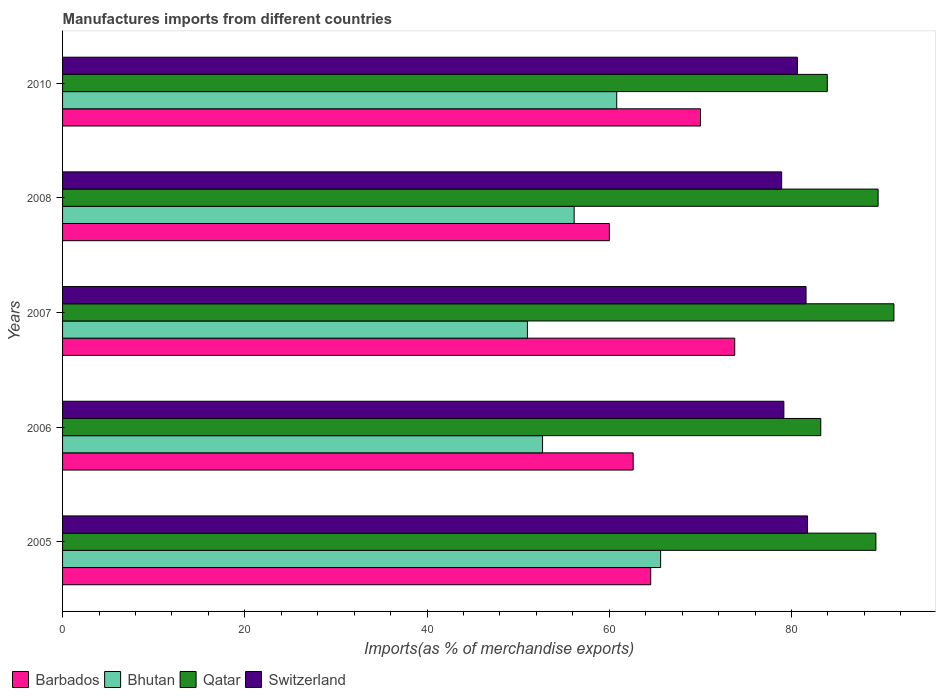How many different coloured bars are there?
Your response must be concise. 4. How many groups of bars are there?
Your answer should be compact. 5. Are the number of bars per tick equal to the number of legend labels?
Your answer should be very brief. Yes. How many bars are there on the 5th tick from the top?
Ensure brevity in your answer.  4. What is the label of the 2nd group of bars from the top?
Give a very brief answer. 2008. In how many cases, is the number of bars for a given year not equal to the number of legend labels?
Your response must be concise. 0. What is the percentage of imports to different countries in Barbados in 2010?
Your response must be concise. 70.01. Across all years, what is the maximum percentage of imports to different countries in Bhutan?
Keep it short and to the point. 65.64. Across all years, what is the minimum percentage of imports to different countries in Bhutan?
Offer a terse response. 51.02. What is the total percentage of imports to different countries in Barbados in the graph?
Ensure brevity in your answer.  330.98. What is the difference between the percentage of imports to different countries in Qatar in 2005 and that in 2010?
Offer a terse response. 5.34. What is the difference between the percentage of imports to different countries in Barbados in 2010 and the percentage of imports to different countries in Bhutan in 2006?
Give a very brief answer. 17.33. What is the average percentage of imports to different countries in Qatar per year?
Your response must be concise. 87.43. In the year 2005, what is the difference between the percentage of imports to different countries in Barbados and percentage of imports to different countries in Switzerland?
Your answer should be very brief. -17.21. What is the ratio of the percentage of imports to different countries in Switzerland in 2005 to that in 2007?
Provide a succinct answer. 1. Is the percentage of imports to different countries in Switzerland in 2008 less than that in 2010?
Your answer should be very brief. Yes. What is the difference between the highest and the second highest percentage of imports to different countries in Barbados?
Provide a succinct answer. 3.76. What is the difference between the highest and the lowest percentage of imports to different countries in Barbados?
Keep it short and to the point. 13.76. In how many years, is the percentage of imports to different countries in Barbados greater than the average percentage of imports to different countries in Barbados taken over all years?
Your response must be concise. 2. Is the sum of the percentage of imports to different countries in Barbados in 2005 and 2008 greater than the maximum percentage of imports to different countries in Qatar across all years?
Your answer should be compact. Yes. What does the 2nd bar from the top in 2010 represents?
Give a very brief answer. Qatar. What does the 4th bar from the bottom in 2007 represents?
Make the answer very short. Switzerland. Is it the case that in every year, the sum of the percentage of imports to different countries in Switzerland and percentage of imports to different countries in Bhutan is greater than the percentage of imports to different countries in Barbados?
Give a very brief answer. Yes. How many bars are there?
Provide a succinct answer. 20. What is the difference between two consecutive major ticks on the X-axis?
Make the answer very short. 20. Are the values on the major ticks of X-axis written in scientific E-notation?
Offer a terse response. No. Does the graph contain any zero values?
Offer a terse response. No. How are the legend labels stacked?
Ensure brevity in your answer.  Horizontal. What is the title of the graph?
Give a very brief answer. Manufactures imports from different countries. What is the label or title of the X-axis?
Keep it short and to the point. Imports(as % of merchandise exports). What is the label or title of the Y-axis?
Your answer should be compact. Years. What is the Imports(as % of merchandise exports) of Barbados in 2005?
Give a very brief answer. 64.55. What is the Imports(as % of merchandise exports) in Bhutan in 2005?
Keep it short and to the point. 65.64. What is the Imports(as % of merchandise exports) of Qatar in 2005?
Give a very brief answer. 89.27. What is the Imports(as % of merchandise exports) of Switzerland in 2005?
Keep it short and to the point. 81.76. What is the Imports(as % of merchandise exports) of Barbados in 2006?
Keep it short and to the point. 62.63. What is the Imports(as % of merchandise exports) in Bhutan in 2006?
Keep it short and to the point. 52.68. What is the Imports(as % of merchandise exports) of Qatar in 2006?
Provide a short and direct response. 83.21. What is the Imports(as % of merchandise exports) of Switzerland in 2006?
Your answer should be very brief. 79.17. What is the Imports(as % of merchandise exports) of Barbados in 2007?
Your answer should be very brief. 73.77. What is the Imports(as % of merchandise exports) in Bhutan in 2007?
Give a very brief answer. 51.02. What is the Imports(as % of merchandise exports) in Qatar in 2007?
Make the answer very short. 91.24. What is the Imports(as % of merchandise exports) in Switzerland in 2007?
Provide a short and direct response. 81.6. What is the Imports(as % of merchandise exports) of Barbados in 2008?
Ensure brevity in your answer.  60.01. What is the Imports(as % of merchandise exports) of Bhutan in 2008?
Your answer should be compact. 56.15. What is the Imports(as % of merchandise exports) in Qatar in 2008?
Offer a terse response. 89.51. What is the Imports(as % of merchandise exports) in Switzerland in 2008?
Offer a terse response. 78.92. What is the Imports(as % of merchandise exports) in Barbados in 2010?
Provide a short and direct response. 70.01. What is the Imports(as % of merchandise exports) of Bhutan in 2010?
Your response must be concise. 60.82. What is the Imports(as % of merchandise exports) of Qatar in 2010?
Keep it short and to the point. 83.93. What is the Imports(as % of merchandise exports) in Switzerland in 2010?
Ensure brevity in your answer.  80.65. Across all years, what is the maximum Imports(as % of merchandise exports) in Barbados?
Offer a very short reply. 73.77. Across all years, what is the maximum Imports(as % of merchandise exports) in Bhutan?
Ensure brevity in your answer.  65.64. Across all years, what is the maximum Imports(as % of merchandise exports) of Qatar?
Provide a short and direct response. 91.24. Across all years, what is the maximum Imports(as % of merchandise exports) in Switzerland?
Keep it short and to the point. 81.76. Across all years, what is the minimum Imports(as % of merchandise exports) in Barbados?
Your answer should be compact. 60.01. Across all years, what is the minimum Imports(as % of merchandise exports) of Bhutan?
Ensure brevity in your answer.  51.02. Across all years, what is the minimum Imports(as % of merchandise exports) in Qatar?
Ensure brevity in your answer.  83.21. Across all years, what is the minimum Imports(as % of merchandise exports) of Switzerland?
Your answer should be very brief. 78.92. What is the total Imports(as % of merchandise exports) of Barbados in the graph?
Provide a short and direct response. 330.98. What is the total Imports(as % of merchandise exports) of Bhutan in the graph?
Provide a succinct answer. 286.31. What is the total Imports(as % of merchandise exports) in Qatar in the graph?
Give a very brief answer. 437.16. What is the total Imports(as % of merchandise exports) in Switzerland in the graph?
Offer a terse response. 402.1. What is the difference between the Imports(as % of merchandise exports) of Barbados in 2005 and that in 2006?
Make the answer very short. 1.92. What is the difference between the Imports(as % of merchandise exports) in Bhutan in 2005 and that in 2006?
Keep it short and to the point. 12.96. What is the difference between the Imports(as % of merchandise exports) of Qatar in 2005 and that in 2006?
Ensure brevity in your answer.  6.05. What is the difference between the Imports(as % of merchandise exports) in Switzerland in 2005 and that in 2006?
Make the answer very short. 2.6. What is the difference between the Imports(as % of merchandise exports) in Barbados in 2005 and that in 2007?
Your response must be concise. -9.22. What is the difference between the Imports(as % of merchandise exports) of Bhutan in 2005 and that in 2007?
Offer a very short reply. 14.62. What is the difference between the Imports(as % of merchandise exports) of Qatar in 2005 and that in 2007?
Give a very brief answer. -1.98. What is the difference between the Imports(as % of merchandise exports) in Switzerland in 2005 and that in 2007?
Give a very brief answer. 0.16. What is the difference between the Imports(as % of merchandise exports) in Barbados in 2005 and that in 2008?
Ensure brevity in your answer.  4.54. What is the difference between the Imports(as % of merchandise exports) of Bhutan in 2005 and that in 2008?
Ensure brevity in your answer.  9.49. What is the difference between the Imports(as % of merchandise exports) of Qatar in 2005 and that in 2008?
Provide a succinct answer. -0.24. What is the difference between the Imports(as % of merchandise exports) of Switzerland in 2005 and that in 2008?
Your answer should be compact. 2.84. What is the difference between the Imports(as % of merchandise exports) in Barbados in 2005 and that in 2010?
Your response must be concise. -5.46. What is the difference between the Imports(as % of merchandise exports) of Bhutan in 2005 and that in 2010?
Ensure brevity in your answer.  4.82. What is the difference between the Imports(as % of merchandise exports) in Qatar in 2005 and that in 2010?
Ensure brevity in your answer.  5.34. What is the difference between the Imports(as % of merchandise exports) in Switzerland in 2005 and that in 2010?
Provide a succinct answer. 1.11. What is the difference between the Imports(as % of merchandise exports) in Barbados in 2006 and that in 2007?
Ensure brevity in your answer.  -11.15. What is the difference between the Imports(as % of merchandise exports) of Bhutan in 2006 and that in 2007?
Offer a terse response. 1.66. What is the difference between the Imports(as % of merchandise exports) of Qatar in 2006 and that in 2007?
Give a very brief answer. -8.03. What is the difference between the Imports(as % of merchandise exports) in Switzerland in 2006 and that in 2007?
Keep it short and to the point. -2.44. What is the difference between the Imports(as % of merchandise exports) of Barbados in 2006 and that in 2008?
Offer a very short reply. 2.61. What is the difference between the Imports(as % of merchandise exports) in Bhutan in 2006 and that in 2008?
Provide a succinct answer. -3.47. What is the difference between the Imports(as % of merchandise exports) of Qatar in 2006 and that in 2008?
Give a very brief answer. -6.29. What is the difference between the Imports(as % of merchandise exports) in Switzerland in 2006 and that in 2008?
Offer a very short reply. 0.24. What is the difference between the Imports(as % of merchandise exports) of Barbados in 2006 and that in 2010?
Your answer should be compact. -7.39. What is the difference between the Imports(as % of merchandise exports) in Bhutan in 2006 and that in 2010?
Provide a short and direct response. -8.14. What is the difference between the Imports(as % of merchandise exports) of Qatar in 2006 and that in 2010?
Keep it short and to the point. -0.72. What is the difference between the Imports(as % of merchandise exports) in Switzerland in 2006 and that in 2010?
Keep it short and to the point. -1.49. What is the difference between the Imports(as % of merchandise exports) in Barbados in 2007 and that in 2008?
Ensure brevity in your answer.  13.76. What is the difference between the Imports(as % of merchandise exports) in Bhutan in 2007 and that in 2008?
Keep it short and to the point. -5.13. What is the difference between the Imports(as % of merchandise exports) in Qatar in 2007 and that in 2008?
Give a very brief answer. 1.74. What is the difference between the Imports(as % of merchandise exports) in Switzerland in 2007 and that in 2008?
Your answer should be compact. 2.68. What is the difference between the Imports(as % of merchandise exports) in Barbados in 2007 and that in 2010?
Give a very brief answer. 3.76. What is the difference between the Imports(as % of merchandise exports) in Bhutan in 2007 and that in 2010?
Offer a very short reply. -9.8. What is the difference between the Imports(as % of merchandise exports) in Qatar in 2007 and that in 2010?
Provide a short and direct response. 7.31. What is the difference between the Imports(as % of merchandise exports) in Switzerland in 2007 and that in 2010?
Provide a short and direct response. 0.95. What is the difference between the Imports(as % of merchandise exports) in Barbados in 2008 and that in 2010?
Make the answer very short. -10. What is the difference between the Imports(as % of merchandise exports) of Bhutan in 2008 and that in 2010?
Your response must be concise. -4.67. What is the difference between the Imports(as % of merchandise exports) in Qatar in 2008 and that in 2010?
Give a very brief answer. 5.58. What is the difference between the Imports(as % of merchandise exports) in Switzerland in 2008 and that in 2010?
Your answer should be compact. -1.73. What is the difference between the Imports(as % of merchandise exports) of Barbados in 2005 and the Imports(as % of merchandise exports) of Bhutan in 2006?
Give a very brief answer. 11.87. What is the difference between the Imports(as % of merchandise exports) in Barbados in 2005 and the Imports(as % of merchandise exports) in Qatar in 2006?
Your answer should be very brief. -18.66. What is the difference between the Imports(as % of merchandise exports) in Barbados in 2005 and the Imports(as % of merchandise exports) in Switzerland in 2006?
Make the answer very short. -14.61. What is the difference between the Imports(as % of merchandise exports) in Bhutan in 2005 and the Imports(as % of merchandise exports) in Qatar in 2006?
Ensure brevity in your answer.  -17.58. What is the difference between the Imports(as % of merchandise exports) of Bhutan in 2005 and the Imports(as % of merchandise exports) of Switzerland in 2006?
Offer a very short reply. -13.53. What is the difference between the Imports(as % of merchandise exports) of Qatar in 2005 and the Imports(as % of merchandise exports) of Switzerland in 2006?
Keep it short and to the point. 10.1. What is the difference between the Imports(as % of merchandise exports) of Barbados in 2005 and the Imports(as % of merchandise exports) of Bhutan in 2007?
Ensure brevity in your answer.  13.53. What is the difference between the Imports(as % of merchandise exports) in Barbados in 2005 and the Imports(as % of merchandise exports) in Qatar in 2007?
Your answer should be very brief. -26.69. What is the difference between the Imports(as % of merchandise exports) in Barbados in 2005 and the Imports(as % of merchandise exports) in Switzerland in 2007?
Keep it short and to the point. -17.05. What is the difference between the Imports(as % of merchandise exports) in Bhutan in 2005 and the Imports(as % of merchandise exports) in Qatar in 2007?
Make the answer very short. -25.61. What is the difference between the Imports(as % of merchandise exports) in Bhutan in 2005 and the Imports(as % of merchandise exports) in Switzerland in 2007?
Keep it short and to the point. -15.96. What is the difference between the Imports(as % of merchandise exports) in Qatar in 2005 and the Imports(as % of merchandise exports) in Switzerland in 2007?
Keep it short and to the point. 7.67. What is the difference between the Imports(as % of merchandise exports) in Barbados in 2005 and the Imports(as % of merchandise exports) in Bhutan in 2008?
Keep it short and to the point. 8.4. What is the difference between the Imports(as % of merchandise exports) in Barbados in 2005 and the Imports(as % of merchandise exports) in Qatar in 2008?
Make the answer very short. -24.96. What is the difference between the Imports(as % of merchandise exports) in Barbados in 2005 and the Imports(as % of merchandise exports) in Switzerland in 2008?
Provide a succinct answer. -14.37. What is the difference between the Imports(as % of merchandise exports) of Bhutan in 2005 and the Imports(as % of merchandise exports) of Qatar in 2008?
Give a very brief answer. -23.87. What is the difference between the Imports(as % of merchandise exports) in Bhutan in 2005 and the Imports(as % of merchandise exports) in Switzerland in 2008?
Ensure brevity in your answer.  -13.28. What is the difference between the Imports(as % of merchandise exports) in Qatar in 2005 and the Imports(as % of merchandise exports) in Switzerland in 2008?
Give a very brief answer. 10.34. What is the difference between the Imports(as % of merchandise exports) in Barbados in 2005 and the Imports(as % of merchandise exports) in Bhutan in 2010?
Your answer should be very brief. 3.73. What is the difference between the Imports(as % of merchandise exports) in Barbados in 2005 and the Imports(as % of merchandise exports) in Qatar in 2010?
Your response must be concise. -19.38. What is the difference between the Imports(as % of merchandise exports) in Barbados in 2005 and the Imports(as % of merchandise exports) in Switzerland in 2010?
Make the answer very short. -16.1. What is the difference between the Imports(as % of merchandise exports) in Bhutan in 2005 and the Imports(as % of merchandise exports) in Qatar in 2010?
Your answer should be very brief. -18.29. What is the difference between the Imports(as % of merchandise exports) of Bhutan in 2005 and the Imports(as % of merchandise exports) of Switzerland in 2010?
Offer a very short reply. -15.01. What is the difference between the Imports(as % of merchandise exports) of Qatar in 2005 and the Imports(as % of merchandise exports) of Switzerland in 2010?
Give a very brief answer. 8.61. What is the difference between the Imports(as % of merchandise exports) of Barbados in 2006 and the Imports(as % of merchandise exports) of Bhutan in 2007?
Offer a terse response. 11.61. What is the difference between the Imports(as % of merchandise exports) in Barbados in 2006 and the Imports(as % of merchandise exports) in Qatar in 2007?
Your response must be concise. -28.62. What is the difference between the Imports(as % of merchandise exports) in Barbados in 2006 and the Imports(as % of merchandise exports) in Switzerland in 2007?
Your answer should be very brief. -18.97. What is the difference between the Imports(as % of merchandise exports) of Bhutan in 2006 and the Imports(as % of merchandise exports) of Qatar in 2007?
Give a very brief answer. -38.56. What is the difference between the Imports(as % of merchandise exports) in Bhutan in 2006 and the Imports(as % of merchandise exports) in Switzerland in 2007?
Your response must be concise. -28.92. What is the difference between the Imports(as % of merchandise exports) of Qatar in 2006 and the Imports(as % of merchandise exports) of Switzerland in 2007?
Give a very brief answer. 1.61. What is the difference between the Imports(as % of merchandise exports) in Barbados in 2006 and the Imports(as % of merchandise exports) in Bhutan in 2008?
Keep it short and to the point. 6.48. What is the difference between the Imports(as % of merchandise exports) of Barbados in 2006 and the Imports(as % of merchandise exports) of Qatar in 2008?
Provide a short and direct response. -26.88. What is the difference between the Imports(as % of merchandise exports) in Barbados in 2006 and the Imports(as % of merchandise exports) in Switzerland in 2008?
Provide a short and direct response. -16.3. What is the difference between the Imports(as % of merchandise exports) of Bhutan in 2006 and the Imports(as % of merchandise exports) of Qatar in 2008?
Give a very brief answer. -36.83. What is the difference between the Imports(as % of merchandise exports) in Bhutan in 2006 and the Imports(as % of merchandise exports) in Switzerland in 2008?
Offer a terse response. -26.24. What is the difference between the Imports(as % of merchandise exports) in Qatar in 2006 and the Imports(as % of merchandise exports) in Switzerland in 2008?
Offer a very short reply. 4.29. What is the difference between the Imports(as % of merchandise exports) of Barbados in 2006 and the Imports(as % of merchandise exports) of Bhutan in 2010?
Provide a succinct answer. 1.8. What is the difference between the Imports(as % of merchandise exports) of Barbados in 2006 and the Imports(as % of merchandise exports) of Qatar in 2010?
Provide a short and direct response. -21.3. What is the difference between the Imports(as % of merchandise exports) in Barbados in 2006 and the Imports(as % of merchandise exports) in Switzerland in 2010?
Your answer should be compact. -18.02. What is the difference between the Imports(as % of merchandise exports) in Bhutan in 2006 and the Imports(as % of merchandise exports) in Qatar in 2010?
Give a very brief answer. -31.25. What is the difference between the Imports(as % of merchandise exports) of Bhutan in 2006 and the Imports(as % of merchandise exports) of Switzerland in 2010?
Give a very brief answer. -27.97. What is the difference between the Imports(as % of merchandise exports) in Qatar in 2006 and the Imports(as % of merchandise exports) in Switzerland in 2010?
Provide a succinct answer. 2.56. What is the difference between the Imports(as % of merchandise exports) in Barbados in 2007 and the Imports(as % of merchandise exports) in Bhutan in 2008?
Your response must be concise. 17.62. What is the difference between the Imports(as % of merchandise exports) of Barbados in 2007 and the Imports(as % of merchandise exports) of Qatar in 2008?
Provide a succinct answer. -15.74. What is the difference between the Imports(as % of merchandise exports) of Barbados in 2007 and the Imports(as % of merchandise exports) of Switzerland in 2008?
Provide a succinct answer. -5.15. What is the difference between the Imports(as % of merchandise exports) in Bhutan in 2007 and the Imports(as % of merchandise exports) in Qatar in 2008?
Offer a very short reply. -38.49. What is the difference between the Imports(as % of merchandise exports) of Bhutan in 2007 and the Imports(as % of merchandise exports) of Switzerland in 2008?
Provide a short and direct response. -27.9. What is the difference between the Imports(as % of merchandise exports) of Qatar in 2007 and the Imports(as % of merchandise exports) of Switzerland in 2008?
Your answer should be very brief. 12.32. What is the difference between the Imports(as % of merchandise exports) in Barbados in 2007 and the Imports(as % of merchandise exports) in Bhutan in 2010?
Provide a succinct answer. 12.95. What is the difference between the Imports(as % of merchandise exports) of Barbados in 2007 and the Imports(as % of merchandise exports) of Qatar in 2010?
Your response must be concise. -10.16. What is the difference between the Imports(as % of merchandise exports) in Barbados in 2007 and the Imports(as % of merchandise exports) in Switzerland in 2010?
Your answer should be compact. -6.88. What is the difference between the Imports(as % of merchandise exports) of Bhutan in 2007 and the Imports(as % of merchandise exports) of Qatar in 2010?
Your answer should be very brief. -32.91. What is the difference between the Imports(as % of merchandise exports) of Bhutan in 2007 and the Imports(as % of merchandise exports) of Switzerland in 2010?
Make the answer very short. -29.63. What is the difference between the Imports(as % of merchandise exports) in Qatar in 2007 and the Imports(as % of merchandise exports) in Switzerland in 2010?
Make the answer very short. 10.59. What is the difference between the Imports(as % of merchandise exports) of Barbados in 2008 and the Imports(as % of merchandise exports) of Bhutan in 2010?
Your answer should be very brief. -0.81. What is the difference between the Imports(as % of merchandise exports) of Barbados in 2008 and the Imports(as % of merchandise exports) of Qatar in 2010?
Give a very brief answer. -23.92. What is the difference between the Imports(as % of merchandise exports) in Barbados in 2008 and the Imports(as % of merchandise exports) in Switzerland in 2010?
Give a very brief answer. -20.64. What is the difference between the Imports(as % of merchandise exports) in Bhutan in 2008 and the Imports(as % of merchandise exports) in Qatar in 2010?
Keep it short and to the point. -27.78. What is the difference between the Imports(as % of merchandise exports) of Bhutan in 2008 and the Imports(as % of merchandise exports) of Switzerland in 2010?
Provide a short and direct response. -24.5. What is the difference between the Imports(as % of merchandise exports) in Qatar in 2008 and the Imports(as % of merchandise exports) in Switzerland in 2010?
Your response must be concise. 8.86. What is the average Imports(as % of merchandise exports) of Barbados per year?
Offer a very short reply. 66.2. What is the average Imports(as % of merchandise exports) in Bhutan per year?
Offer a terse response. 57.26. What is the average Imports(as % of merchandise exports) of Qatar per year?
Keep it short and to the point. 87.43. What is the average Imports(as % of merchandise exports) in Switzerland per year?
Offer a terse response. 80.42. In the year 2005, what is the difference between the Imports(as % of merchandise exports) of Barbados and Imports(as % of merchandise exports) of Bhutan?
Provide a short and direct response. -1.09. In the year 2005, what is the difference between the Imports(as % of merchandise exports) of Barbados and Imports(as % of merchandise exports) of Qatar?
Your answer should be compact. -24.71. In the year 2005, what is the difference between the Imports(as % of merchandise exports) in Barbados and Imports(as % of merchandise exports) in Switzerland?
Give a very brief answer. -17.21. In the year 2005, what is the difference between the Imports(as % of merchandise exports) in Bhutan and Imports(as % of merchandise exports) in Qatar?
Ensure brevity in your answer.  -23.63. In the year 2005, what is the difference between the Imports(as % of merchandise exports) of Bhutan and Imports(as % of merchandise exports) of Switzerland?
Give a very brief answer. -16.13. In the year 2005, what is the difference between the Imports(as % of merchandise exports) of Qatar and Imports(as % of merchandise exports) of Switzerland?
Provide a short and direct response. 7.5. In the year 2006, what is the difference between the Imports(as % of merchandise exports) in Barbados and Imports(as % of merchandise exports) in Bhutan?
Make the answer very short. 9.95. In the year 2006, what is the difference between the Imports(as % of merchandise exports) in Barbados and Imports(as % of merchandise exports) in Qatar?
Your response must be concise. -20.59. In the year 2006, what is the difference between the Imports(as % of merchandise exports) in Barbados and Imports(as % of merchandise exports) in Switzerland?
Offer a terse response. -16.54. In the year 2006, what is the difference between the Imports(as % of merchandise exports) in Bhutan and Imports(as % of merchandise exports) in Qatar?
Your answer should be very brief. -30.53. In the year 2006, what is the difference between the Imports(as % of merchandise exports) in Bhutan and Imports(as % of merchandise exports) in Switzerland?
Offer a very short reply. -26.49. In the year 2006, what is the difference between the Imports(as % of merchandise exports) of Qatar and Imports(as % of merchandise exports) of Switzerland?
Offer a very short reply. 4.05. In the year 2007, what is the difference between the Imports(as % of merchandise exports) of Barbados and Imports(as % of merchandise exports) of Bhutan?
Provide a succinct answer. 22.75. In the year 2007, what is the difference between the Imports(as % of merchandise exports) in Barbados and Imports(as % of merchandise exports) in Qatar?
Provide a short and direct response. -17.47. In the year 2007, what is the difference between the Imports(as % of merchandise exports) in Barbados and Imports(as % of merchandise exports) in Switzerland?
Your answer should be compact. -7.83. In the year 2007, what is the difference between the Imports(as % of merchandise exports) of Bhutan and Imports(as % of merchandise exports) of Qatar?
Ensure brevity in your answer.  -40.22. In the year 2007, what is the difference between the Imports(as % of merchandise exports) of Bhutan and Imports(as % of merchandise exports) of Switzerland?
Make the answer very short. -30.58. In the year 2007, what is the difference between the Imports(as % of merchandise exports) of Qatar and Imports(as % of merchandise exports) of Switzerland?
Your answer should be compact. 9.64. In the year 2008, what is the difference between the Imports(as % of merchandise exports) in Barbados and Imports(as % of merchandise exports) in Bhutan?
Keep it short and to the point. 3.87. In the year 2008, what is the difference between the Imports(as % of merchandise exports) in Barbados and Imports(as % of merchandise exports) in Qatar?
Provide a short and direct response. -29.49. In the year 2008, what is the difference between the Imports(as % of merchandise exports) in Barbados and Imports(as % of merchandise exports) in Switzerland?
Offer a very short reply. -18.91. In the year 2008, what is the difference between the Imports(as % of merchandise exports) of Bhutan and Imports(as % of merchandise exports) of Qatar?
Provide a short and direct response. -33.36. In the year 2008, what is the difference between the Imports(as % of merchandise exports) of Bhutan and Imports(as % of merchandise exports) of Switzerland?
Provide a succinct answer. -22.77. In the year 2008, what is the difference between the Imports(as % of merchandise exports) in Qatar and Imports(as % of merchandise exports) in Switzerland?
Ensure brevity in your answer.  10.59. In the year 2010, what is the difference between the Imports(as % of merchandise exports) of Barbados and Imports(as % of merchandise exports) of Bhutan?
Provide a succinct answer. 9.19. In the year 2010, what is the difference between the Imports(as % of merchandise exports) in Barbados and Imports(as % of merchandise exports) in Qatar?
Provide a short and direct response. -13.92. In the year 2010, what is the difference between the Imports(as % of merchandise exports) in Barbados and Imports(as % of merchandise exports) in Switzerland?
Give a very brief answer. -10.64. In the year 2010, what is the difference between the Imports(as % of merchandise exports) of Bhutan and Imports(as % of merchandise exports) of Qatar?
Make the answer very short. -23.11. In the year 2010, what is the difference between the Imports(as % of merchandise exports) of Bhutan and Imports(as % of merchandise exports) of Switzerland?
Offer a very short reply. -19.83. In the year 2010, what is the difference between the Imports(as % of merchandise exports) of Qatar and Imports(as % of merchandise exports) of Switzerland?
Your answer should be very brief. 3.28. What is the ratio of the Imports(as % of merchandise exports) of Barbados in 2005 to that in 2006?
Ensure brevity in your answer.  1.03. What is the ratio of the Imports(as % of merchandise exports) of Bhutan in 2005 to that in 2006?
Offer a terse response. 1.25. What is the ratio of the Imports(as % of merchandise exports) in Qatar in 2005 to that in 2006?
Keep it short and to the point. 1.07. What is the ratio of the Imports(as % of merchandise exports) in Switzerland in 2005 to that in 2006?
Provide a short and direct response. 1.03. What is the ratio of the Imports(as % of merchandise exports) in Bhutan in 2005 to that in 2007?
Offer a terse response. 1.29. What is the ratio of the Imports(as % of merchandise exports) of Qatar in 2005 to that in 2007?
Keep it short and to the point. 0.98. What is the ratio of the Imports(as % of merchandise exports) of Barbados in 2005 to that in 2008?
Your answer should be very brief. 1.08. What is the ratio of the Imports(as % of merchandise exports) in Bhutan in 2005 to that in 2008?
Your response must be concise. 1.17. What is the ratio of the Imports(as % of merchandise exports) in Switzerland in 2005 to that in 2008?
Your answer should be compact. 1.04. What is the ratio of the Imports(as % of merchandise exports) of Barbados in 2005 to that in 2010?
Your answer should be very brief. 0.92. What is the ratio of the Imports(as % of merchandise exports) of Bhutan in 2005 to that in 2010?
Your response must be concise. 1.08. What is the ratio of the Imports(as % of merchandise exports) of Qatar in 2005 to that in 2010?
Offer a terse response. 1.06. What is the ratio of the Imports(as % of merchandise exports) in Switzerland in 2005 to that in 2010?
Your answer should be very brief. 1.01. What is the ratio of the Imports(as % of merchandise exports) in Barbados in 2006 to that in 2007?
Keep it short and to the point. 0.85. What is the ratio of the Imports(as % of merchandise exports) of Bhutan in 2006 to that in 2007?
Your answer should be compact. 1.03. What is the ratio of the Imports(as % of merchandise exports) of Qatar in 2006 to that in 2007?
Offer a terse response. 0.91. What is the ratio of the Imports(as % of merchandise exports) in Switzerland in 2006 to that in 2007?
Ensure brevity in your answer.  0.97. What is the ratio of the Imports(as % of merchandise exports) of Barbados in 2006 to that in 2008?
Your response must be concise. 1.04. What is the ratio of the Imports(as % of merchandise exports) in Bhutan in 2006 to that in 2008?
Keep it short and to the point. 0.94. What is the ratio of the Imports(as % of merchandise exports) in Qatar in 2006 to that in 2008?
Your answer should be compact. 0.93. What is the ratio of the Imports(as % of merchandise exports) of Switzerland in 2006 to that in 2008?
Give a very brief answer. 1. What is the ratio of the Imports(as % of merchandise exports) in Barbados in 2006 to that in 2010?
Give a very brief answer. 0.89. What is the ratio of the Imports(as % of merchandise exports) in Bhutan in 2006 to that in 2010?
Provide a short and direct response. 0.87. What is the ratio of the Imports(as % of merchandise exports) in Switzerland in 2006 to that in 2010?
Your answer should be very brief. 0.98. What is the ratio of the Imports(as % of merchandise exports) in Barbados in 2007 to that in 2008?
Give a very brief answer. 1.23. What is the ratio of the Imports(as % of merchandise exports) in Bhutan in 2007 to that in 2008?
Your answer should be compact. 0.91. What is the ratio of the Imports(as % of merchandise exports) of Qatar in 2007 to that in 2008?
Provide a succinct answer. 1.02. What is the ratio of the Imports(as % of merchandise exports) in Switzerland in 2007 to that in 2008?
Your response must be concise. 1.03. What is the ratio of the Imports(as % of merchandise exports) in Barbados in 2007 to that in 2010?
Provide a succinct answer. 1.05. What is the ratio of the Imports(as % of merchandise exports) in Bhutan in 2007 to that in 2010?
Give a very brief answer. 0.84. What is the ratio of the Imports(as % of merchandise exports) in Qatar in 2007 to that in 2010?
Make the answer very short. 1.09. What is the ratio of the Imports(as % of merchandise exports) of Switzerland in 2007 to that in 2010?
Give a very brief answer. 1.01. What is the ratio of the Imports(as % of merchandise exports) of Barbados in 2008 to that in 2010?
Provide a succinct answer. 0.86. What is the ratio of the Imports(as % of merchandise exports) in Bhutan in 2008 to that in 2010?
Ensure brevity in your answer.  0.92. What is the ratio of the Imports(as % of merchandise exports) of Qatar in 2008 to that in 2010?
Keep it short and to the point. 1.07. What is the ratio of the Imports(as % of merchandise exports) in Switzerland in 2008 to that in 2010?
Provide a short and direct response. 0.98. What is the difference between the highest and the second highest Imports(as % of merchandise exports) of Barbados?
Ensure brevity in your answer.  3.76. What is the difference between the highest and the second highest Imports(as % of merchandise exports) of Bhutan?
Your response must be concise. 4.82. What is the difference between the highest and the second highest Imports(as % of merchandise exports) of Qatar?
Your response must be concise. 1.74. What is the difference between the highest and the second highest Imports(as % of merchandise exports) of Switzerland?
Ensure brevity in your answer.  0.16. What is the difference between the highest and the lowest Imports(as % of merchandise exports) in Barbados?
Ensure brevity in your answer.  13.76. What is the difference between the highest and the lowest Imports(as % of merchandise exports) of Bhutan?
Offer a very short reply. 14.62. What is the difference between the highest and the lowest Imports(as % of merchandise exports) of Qatar?
Keep it short and to the point. 8.03. What is the difference between the highest and the lowest Imports(as % of merchandise exports) in Switzerland?
Your response must be concise. 2.84. 